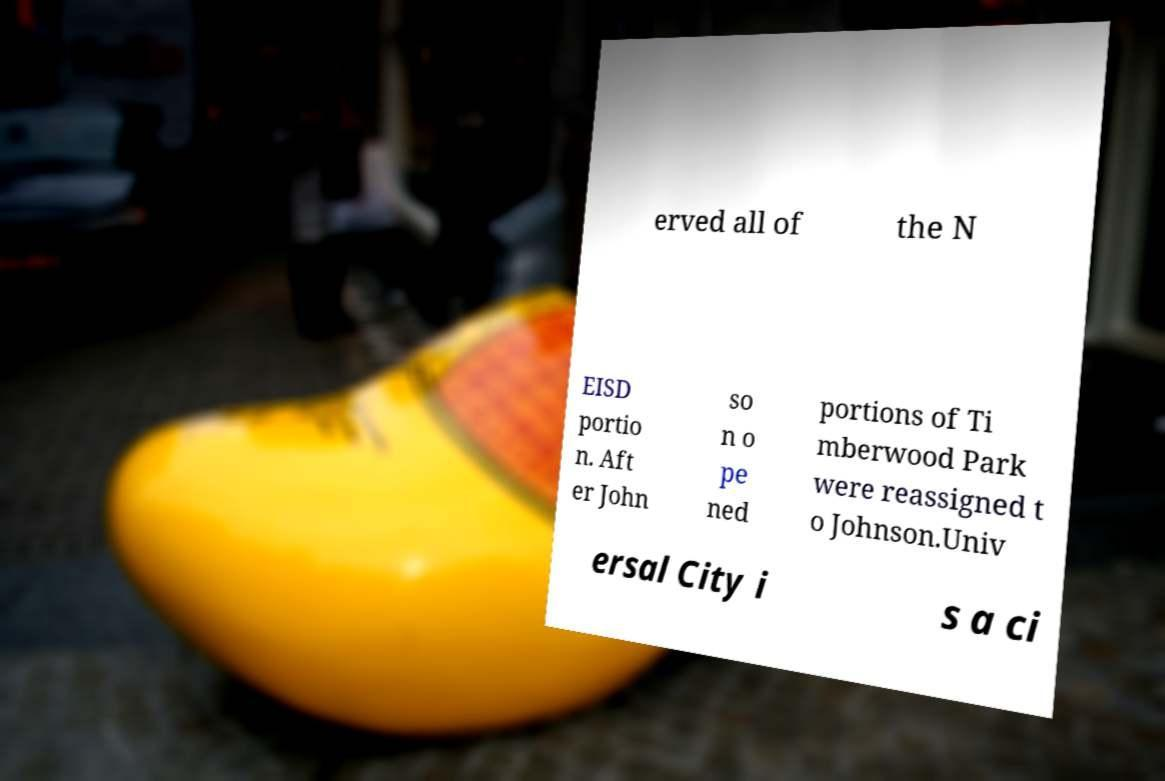Can you accurately transcribe the text from the provided image for me? erved all of the N EISD portio n. Aft er John so n o pe ned portions of Ti mberwood Park were reassigned t o Johnson.Univ ersal City i s a ci 